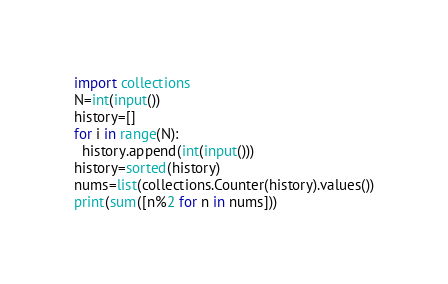Convert code to text. <code><loc_0><loc_0><loc_500><loc_500><_Python_>import collections
N=int(input())
history=[]
for i in range(N):
  history.append(int(input()))
history=sorted(history)
nums=list(collections.Counter(history).values())
print(sum([n%2 for n in nums]))</code> 